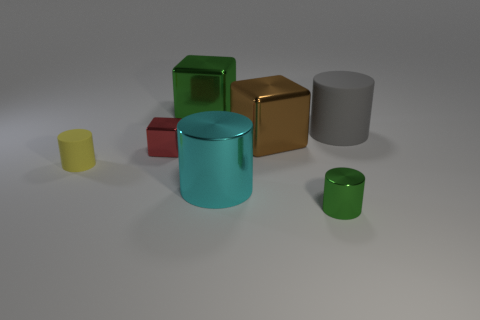What number of big things are blue rubber things or metal things?
Your response must be concise. 3. There is a big shiny thing that is behind the gray rubber cylinder; does it have the same shape as the green thing in front of the gray cylinder?
Provide a succinct answer. No. What size is the rubber object to the left of the green metal object that is right of the green object behind the big matte thing?
Ensure brevity in your answer.  Small. There is a rubber object in front of the red object; what is its size?
Provide a succinct answer. Small. What material is the big green cube that is to the left of the small green metal cylinder?
Offer a very short reply. Metal. How many gray objects are metal things or small shiny cylinders?
Your response must be concise. 0. Do the red thing and the large cylinder that is in front of the red thing have the same material?
Offer a terse response. Yes. Are there an equal number of gray matte cylinders to the left of the yellow rubber cylinder and rubber things right of the red cube?
Ensure brevity in your answer.  No. Does the yellow matte cylinder have the same size as the green metallic object that is to the right of the cyan metal object?
Your response must be concise. Yes. Are there more large metal things that are in front of the red metallic cube than small green rubber cubes?
Offer a very short reply. Yes. 